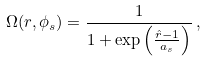Convert formula to latex. <formula><loc_0><loc_0><loc_500><loc_500>\Omega ( r , \phi _ { s } ) = \frac { 1 } { 1 + \exp \left ( \frac { \hat { r } - 1 } { a _ { s } } \right ) } \, ,</formula> 